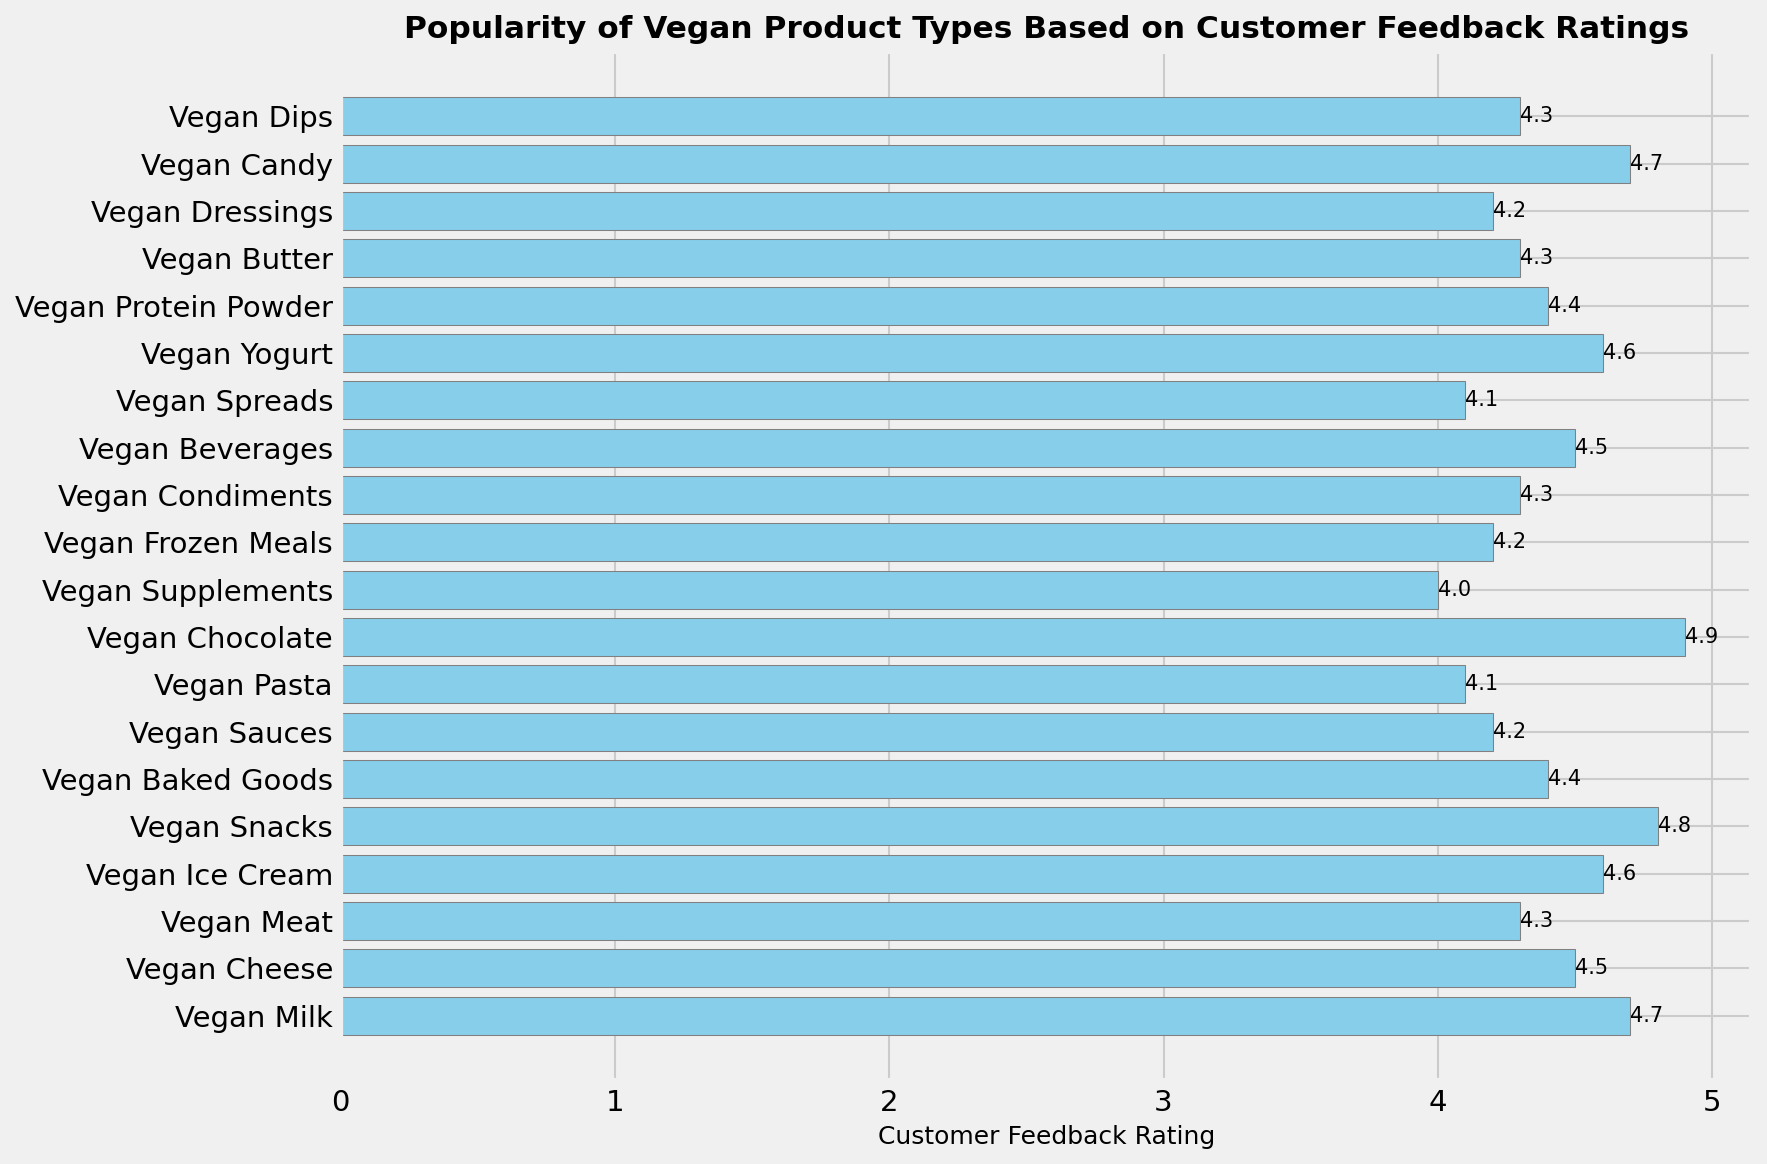Which vegan product type received the highest customer feedback rating? The Vegan Chocolate bar has the largest horizontal extent, which shows it scored the highest customer feedback rating at 4.9.
Answer: Vegan Chocolate Which vegan product type received the lowest customer feedback rating? The Vegan Supplements bar has the smallest horizontal extent, which corresponds to the lowest customer feedback rating at 4.0.
Answer: Vegan Supplements What is the average customer feedback rating for Vegan Cheese and Vegan Yogurt? Add the ratings for Vegan Cheese and Vegan Yogurt (4.5 + 4.6) and then divide by 2 to get the average. (4.5 + 4.6)/2 = 4.55
Answer: 4.55 Which product type has a higher rating: Vegan Ice Cream or Vegan Dips? By comparing the horizontal bars, Vegan Ice Cream (4.6) has a higher rating than Vegan Dips (4.3).
Answer: Vegan Ice Cream What’s the difference between the highest and the lowest customer feedback rating? Subtract the rating of the lowest rated product (Vegan Supplements at 4.0) from the highest rated product (Vegan Chocolate at 4.9). 4.9 - 4.0 = 0.9
Answer: 0.9 How many product types have a customer feedback rating of 4.3 or more? Count all the product bars that extend to or beyond the 4.3 mark. 13 product types meet that criterion.
Answer: 13 Which product types have a rating that is exactly 4.3? Locate the horizontal bars that end exactly at the 4.3 rating. These are Vegan Meat, Vegan Condiments, Vegan Butter, and Vegan Dips.
Answer: Vegan Meat, Vegan Condiments, Vegan Butter, Vegan Dips Are there more product types with ratings equal to or above 4.5 or below 4.5? Count the product types: those rated 4.5 or above are Vegan Milk, Vegan Cheese, Vegan Ice Cream, Vegan Snacks, Vegan Chocolate, Vegan Beverages, and Vegan Yogurt, totaling 7. Those below 4.5 are Vegan Baked Goods, Vegan Sauces, Vegan Pasta, Vegan Spreads, Vegan Protein Powder, Vegan Supplements, Vegan Frozen Meals, Vegan Dressings, totaling 10. There are more product types with ratings below 4.5.
Answer: Below 4.5 What is the combined customer feedback rating of Vegan Milk, Vegan Cheese, and Vegan Yogurt? Sum the ratings for Vegan Milk (4.7), Vegan Cheese (4.5), and Vegan Yogurt (4.6). 4.7 + 4.5 + 4.6 = 13.8
Answer: 13.8 Do Vegan Sauces and Vegan Dressings have the same customer feedback rating? Both the Vegan Sauces and Vegan Dressings bars end at the 4.2 rating mark, indicating they have the same rating.
Answer: Yes 